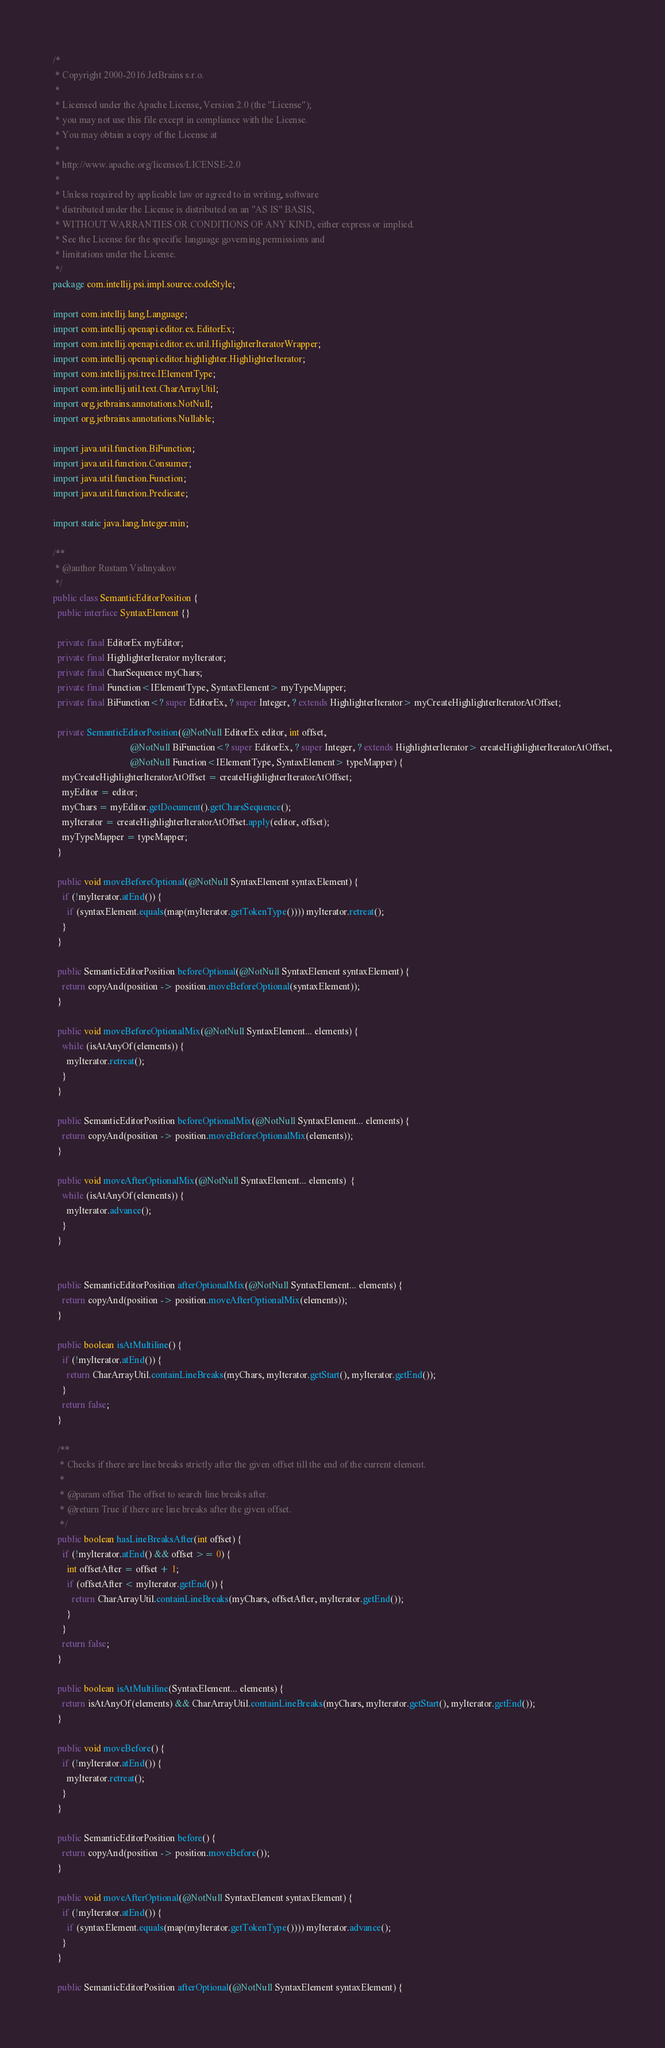Convert code to text. <code><loc_0><loc_0><loc_500><loc_500><_Java_>/*
 * Copyright 2000-2016 JetBrains s.r.o.
 *
 * Licensed under the Apache License, Version 2.0 (the "License");
 * you may not use this file except in compliance with the License.
 * You may obtain a copy of the License at
 *
 * http://www.apache.org/licenses/LICENSE-2.0
 *
 * Unless required by applicable law or agreed to in writing, software
 * distributed under the License is distributed on an "AS IS" BASIS,
 * WITHOUT WARRANTIES OR CONDITIONS OF ANY KIND, either express or implied.
 * See the License for the specific language governing permissions and
 * limitations under the License.
 */
package com.intellij.psi.impl.source.codeStyle;

import com.intellij.lang.Language;
import com.intellij.openapi.editor.ex.EditorEx;
import com.intellij.openapi.editor.ex.util.HighlighterIteratorWrapper;
import com.intellij.openapi.editor.highlighter.HighlighterIterator;
import com.intellij.psi.tree.IElementType;
import com.intellij.util.text.CharArrayUtil;
import org.jetbrains.annotations.NotNull;
import org.jetbrains.annotations.Nullable;

import java.util.function.BiFunction;
import java.util.function.Consumer;
import java.util.function.Function;
import java.util.function.Predicate;

import static java.lang.Integer.min;

/**
 * @author Rustam Vishnyakov
 */
public class SemanticEditorPosition {
  public interface SyntaxElement {}
  
  private final EditorEx myEditor;
  private final HighlighterIterator myIterator;
  private final CharSequence myChars;
  private final Function<IElementType, SyntaxElement> myTypeMapper;
  private final BiFunction<? super EditorEx, ? super Integer, ? extends HighlighterIterator> myCreateHighlighterIteratorAtOffset;

  private SemanticEditorPosition(@NotNull EditorEx editor, int offset,
                                 @NotNull BiFunction<? super EditorEx, ? super Integer, ? extends HighlighterIterator> createHighlighterIteratorAtOffset,
                                 @NotNull Function<IElementType, SyntaxElement> typeMapper) {
    myCreateHighlighterIteratorAtOffset = createHighlighterIteratorAtOffset;
    myEditor = editor;
    myChars = myEditor.getDocument().getCharsSequence();
    myIterator = createHighlighterIteratorAtOffset.apply(editor, offset);
    myTypeMapper = typeMapper;
  }

  public void moveBeforeOptional(@NotNull SyntaxElement syntaxElement) {
    if (!myIterator.atEnd()) {
      if (syntaxElement.equals(map(myIterator.getTokenType()))) myIterator.retreat();
    }
  }

  public SemanticEditorPosition beforeOptional(@NotNull SyntaxElement syntaxElement) {
    return copyAnd(position -> position.moveBeforeOptional(syntaxElement));
  }
  
  public void moveBeforeOptionalMix(@NotNull SyntaxElement... elements) {
    while (isAtAnyOf(elements)) {
      myIterator.retreat();
    }
  }

  public SemanticEditorPosition beforeOptionalMix(@NotNull SyntaxElement... elements) {
    return copyAnd(position -> position.moveBeforeOptionalMix(elements));
  }
  
  public void moveAfterOptionalMix(@NotNull SyntaxElement... elements)  {
    while (isAtAnyOf(elements)) {
      myIterator.advance();
    }
  }


  public SemanticEditorPosition afterOptionalMix(@NotNull SyntaxElement... elements) {
    return copyAnd(position -> position.moveAfterOptionalMix(elements));
  }

  public boolean isAtMultiline() {
    if (!myIterator.atEnd()) {
      return CharArrayUtil.containLineBreaks(myChars, myIterator.getStart(), myIterator.getEnd());
    }
    return false;
  }

  /**
   * Checks if there are line breaks strictly after the given offset till the end of the current element.
   *
   * @param offset The offset to search line breaks after.
   * @return True if there are line breaks after the given offset.
   */
  public boolean hasLineBreaksAfter(int offset) {
    if (!myIterator.atEnd() && offset >= 0) {
      int offsetAfter = offset + 1;
      if (offsetAfter < myIterator.getEnd()) {
        return CharArrayUtil.containLineBreaks(myChars, offsetAfter, myIterator.getEnd());
      }
    }
    return false;
  }

  public boolean isAtMultiline(SyntaxElement... elements) {
    return isAtAnyOf(elements) && CharArrayUtil.containLineBreaks(myChars, myIterator.getStart(), myIterator.getEnd());
  }
  
  public void moveBefore() {
    if (!myIterator.atEnd()) {
      myIterator.retreat();
    }
  }

  public SemanticEditorPosition before() {
    return copyAnd(position -> position.moveBefore());
  }
  
  public void moveAfterOptional(@NotNull SyntaxElement syntaxElement) {
    if (!myIterator.atEnd()) {
      if (syntaxElement.equals(map(myIterator.getTokenType()))) myIterator.advance();
    }
  }

  public SemanticEditorPosition afterOptional(@NotNull SyntaxElement syntaxElement) {</code> 